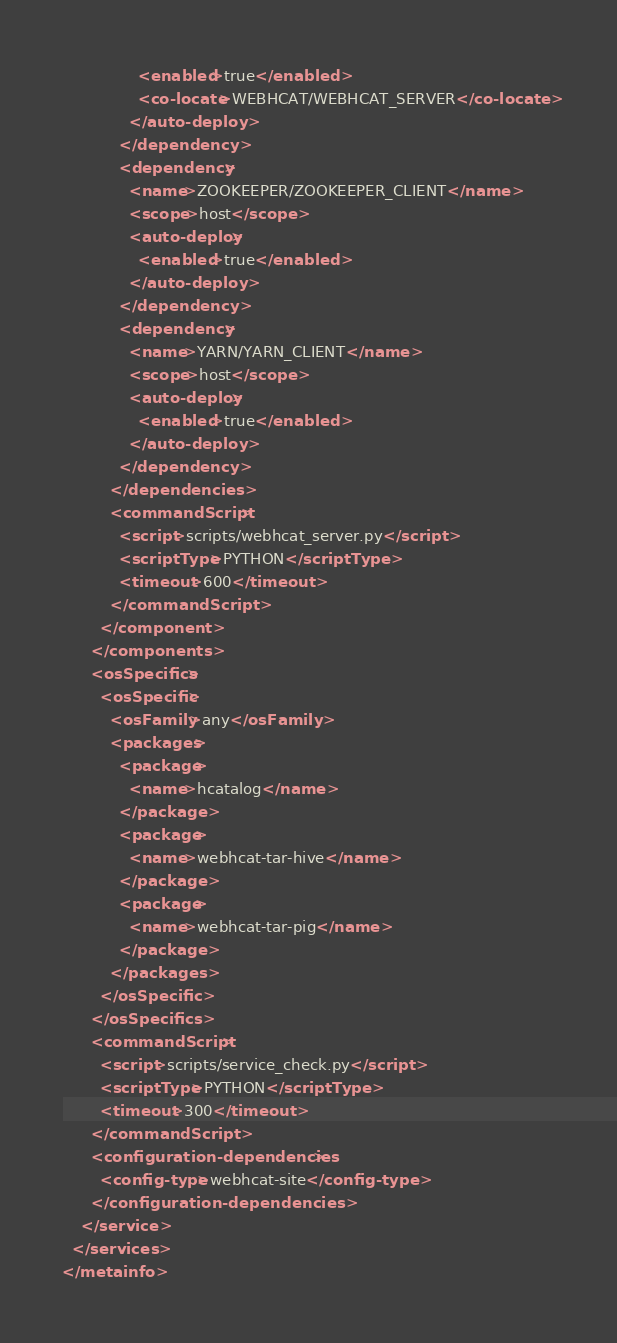Convert code to text. <code><loc_0><loc_0><loc_500><loc_500><_XML_>                <enabled>true</enabled>
                <co-locate>WEBHCAT/WEBHCAT_SERVER</co-locate>
              </auto-deploy>
            </dependency>
            <dependency>
              <name>ZOOKEEPER/ZOOKEEPER_CLIENT</name>
              <scope>host</scope>
              <auto-deploy>
                <enabled>true</enabled>
              </auto-deploy>
            </dependency>
            <dependency>
              <name>YARN/YARN_CLIENT</name>
              <scope>host</scope>
              <auto-deploy>
                <enabled>true</enabled>
              </auto-deploy>
            </dependency>
          </dependencies>
          <commandScript>
            <script>scripts/webhcat_server.py</script>
            <scriptType>PYTHON</scriptType>
            <timeout>600</timeout>
          </commandScript>
        </component>
      </components>
      <osSpecifics>
        <osSpecific>
          <osFamily>any</osFamily>
          <packages>
            <package>
              <name>hcatalog</name>
            </package>
            <package>
              <name>webhcat-tar-hive</name>
            </package>
            <package>
              <name>webhcat-tar-pig</name>
            </package>
          </packages>
        </osSpecific>
      </osSpecifics>
      <commandScript>
        <script>scripts/service_check.py</script>
        <scriptType>PYTHON</scriptType>
        <timeout>300</timeout>
      </commandScript>
      <configuration-dependencies>
        <config-type>webhcat-site</config-type>
      </configuration-dependencies>
    </service>
  </services>
</metainfo>
</code> 